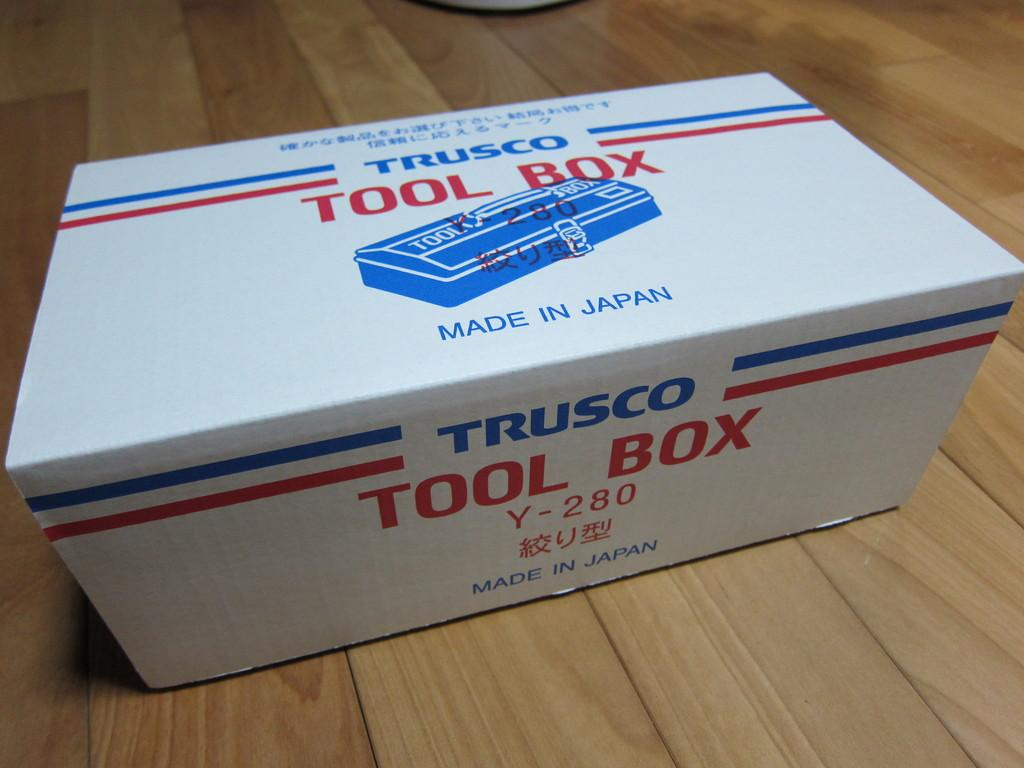<image>
Write a terse but informative summary of the picture. A White Trusco toolbox sits on a wooden table 